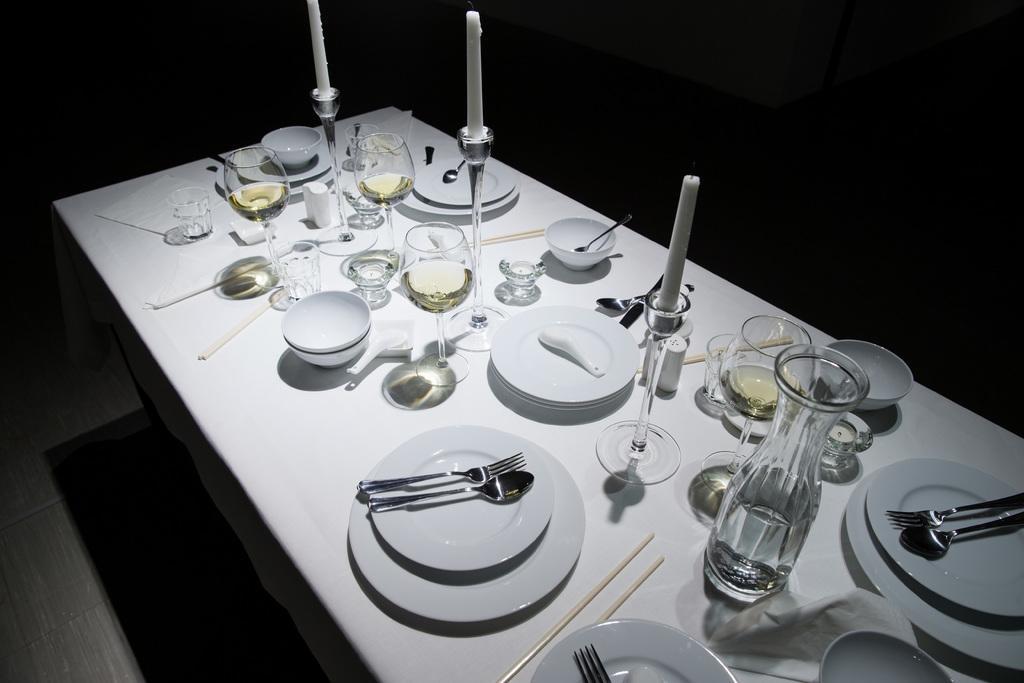Can you describe this image briefly? In this image we can see a table on the floor, there are few plates, bowls, spoons, forks, glasses, few glasses with drink, candle stands with candles and few other objects on the table and dark background. 